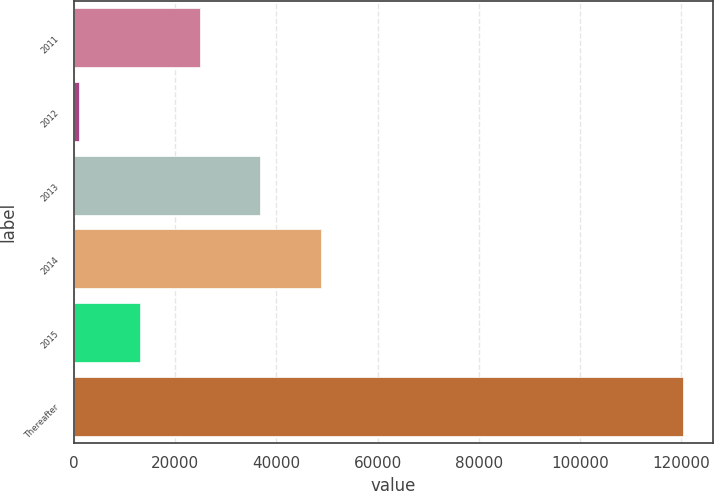Convert chart to OTSL. <chart><loc_0><loc_0><loc_500><loc_500><bar_chart><fcel>2011<fcel>2012<fcel>2013<fcel>2014<fcel>2015<fcel>Thereafter<nl><fcel>24912.6<fcel>1064<fcel>36836.9<fcel>48761.2<fcel>12988.3<fcel>120307<nl></chart> 